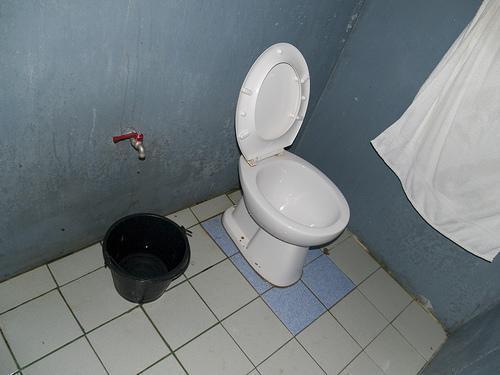How many toilets are there?
Give a very brief answer. 1. How many cars are driving in the opposite direction of the street car?
Give a very brief answer. 0. 